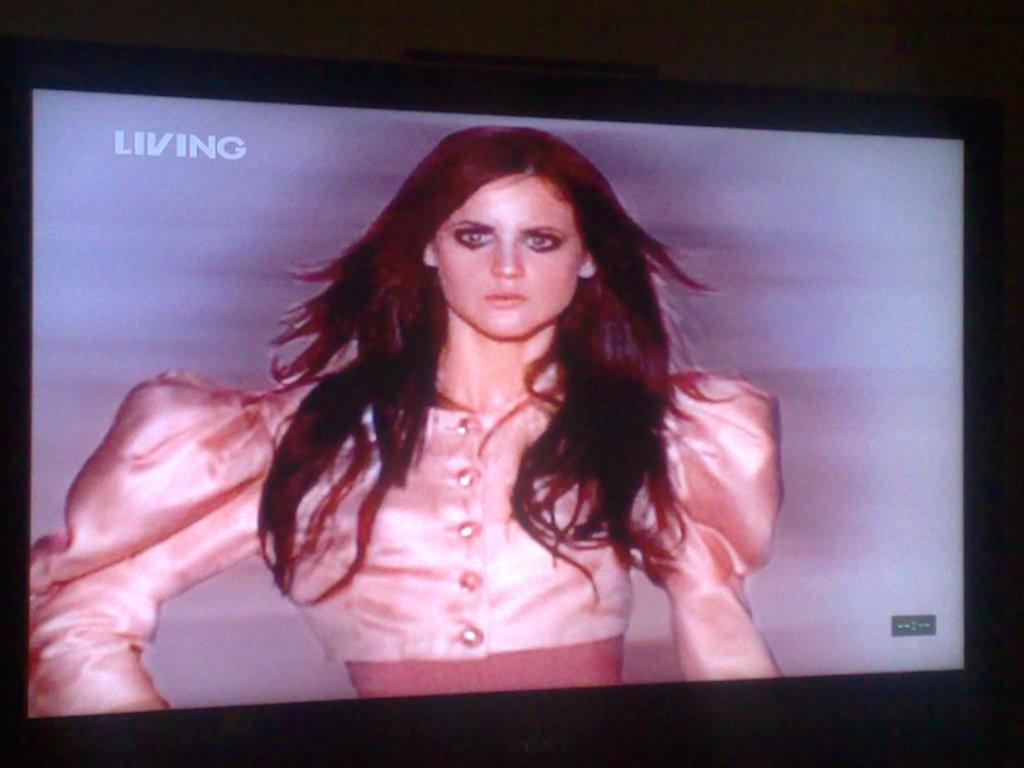Who is the main subject in the image? There is a woman in the image. What is the color of the woman's hair? The woman has brown hair. What is the woman wearing in the image? The woman is wearing a pink dress. How is the image being displayed? The image is displayed on a television. What type of butter is being used to clean the cellar in the image? There is no butter or cellar present in the image; it features a woman with brown hair wearing a pink dress. 